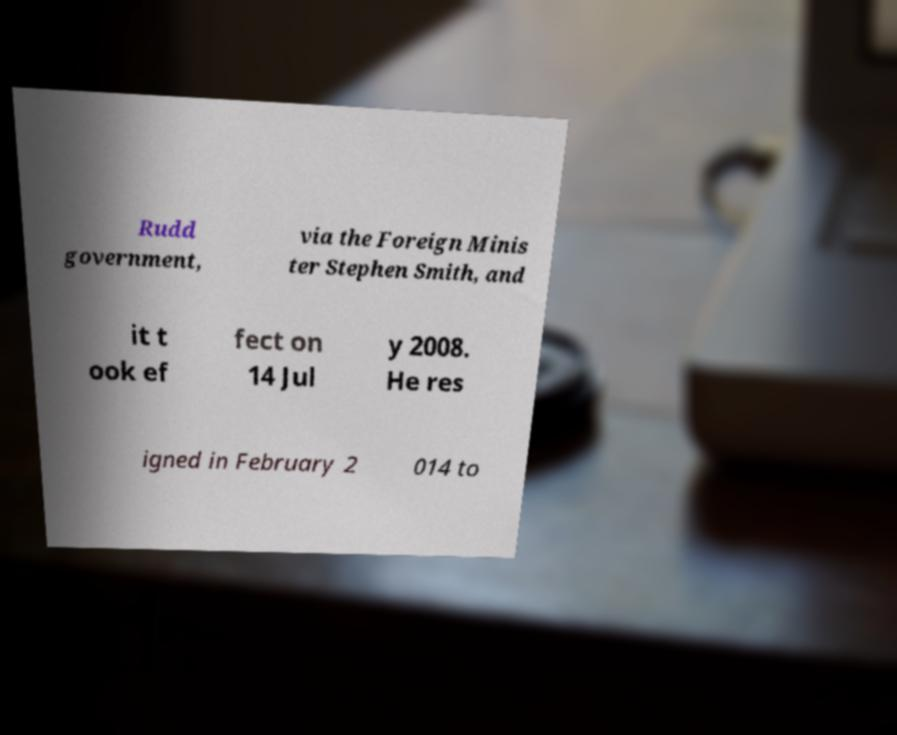There's text embedded in this image that I need extracted. Can you transcribe it verbatim? Rudd government, via the Foreign Minis ter Stephen Smith, and it t ook ef fect on 14 Jul y 2008. He res igned in February 2 014 to 